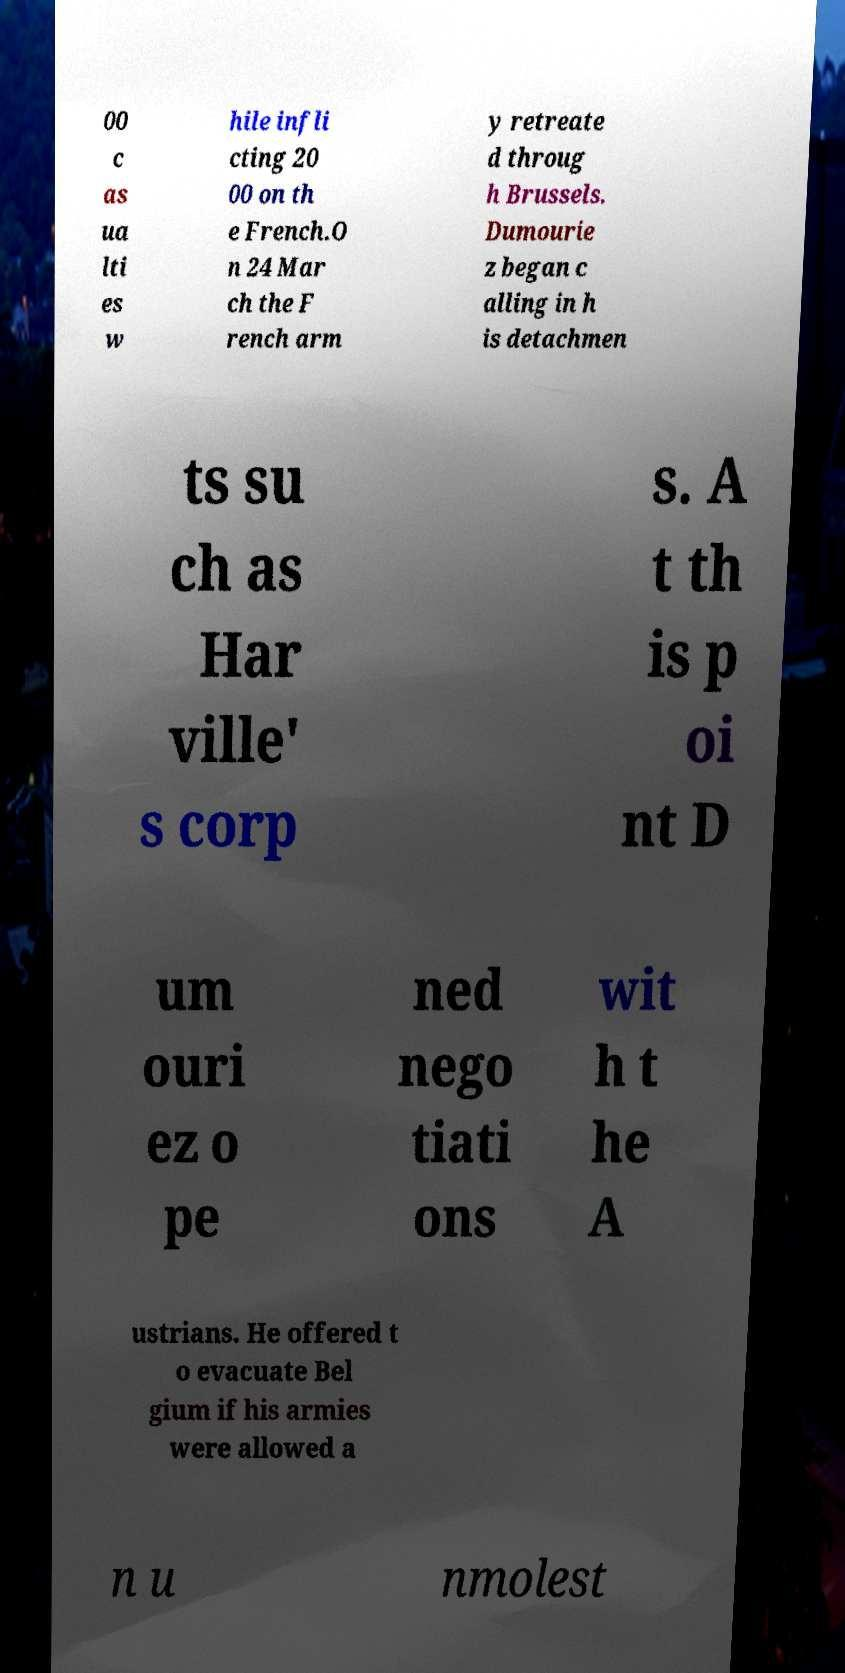Could you extract and type out the text from this image? 00 c as ua lti es w hile infli cting 20 00 on th e French.O n 24 Mar ch the F rench arm y retreate d throug h Brussels. Dumourie z began c alling in h is detachmen ts su ch as Har ville' s corp s. A t th is p oi nt D um ouri ez o pe ned nego tiati ons wit h t he A ustrians. He offered t o evacuate Bel gium if his armies were allowed a n u nmolest 